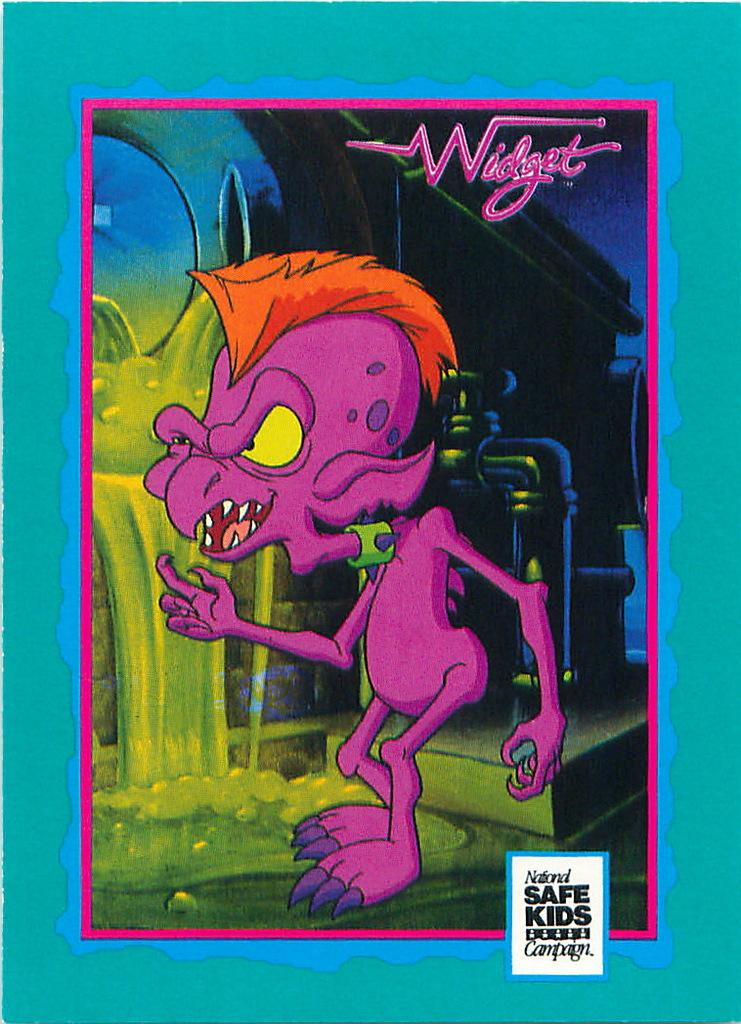<image>
Describe the image concisely. a poster of a purple monster named widget 